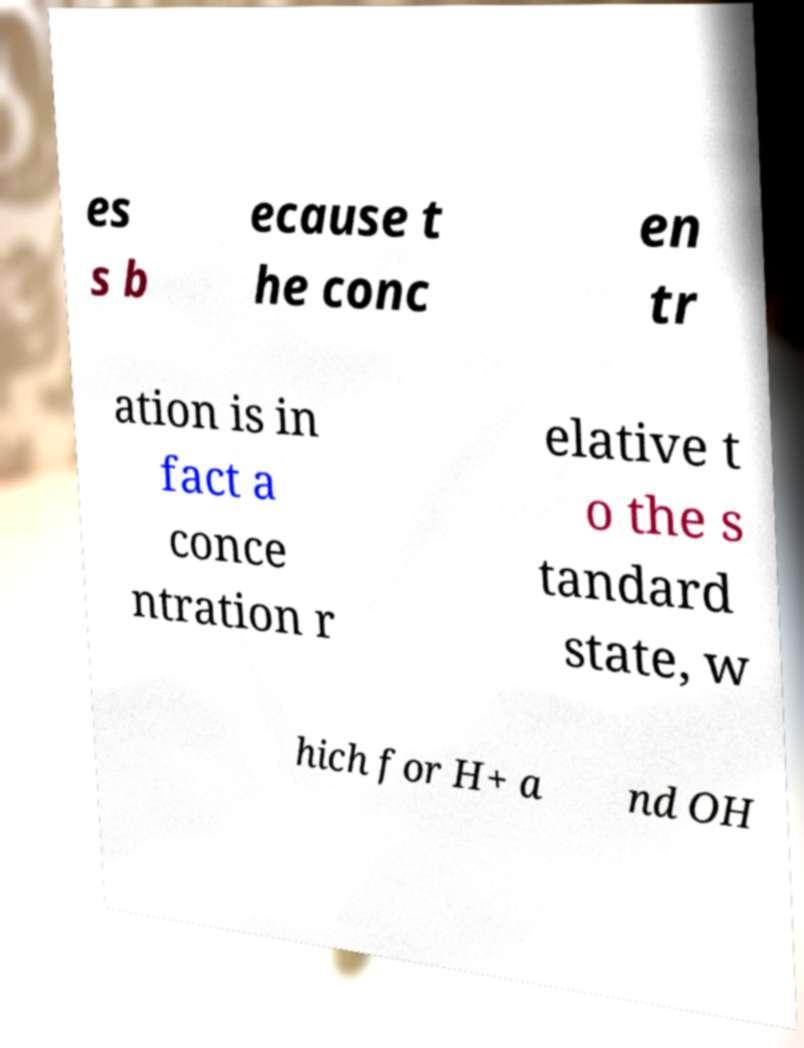I need the written content from this picture converted into text. Can you do that? es s b ecause t he conc en tr ation is in fact a conce ntration r elative t o the s tandard state, w hich for H+ a nd OH 